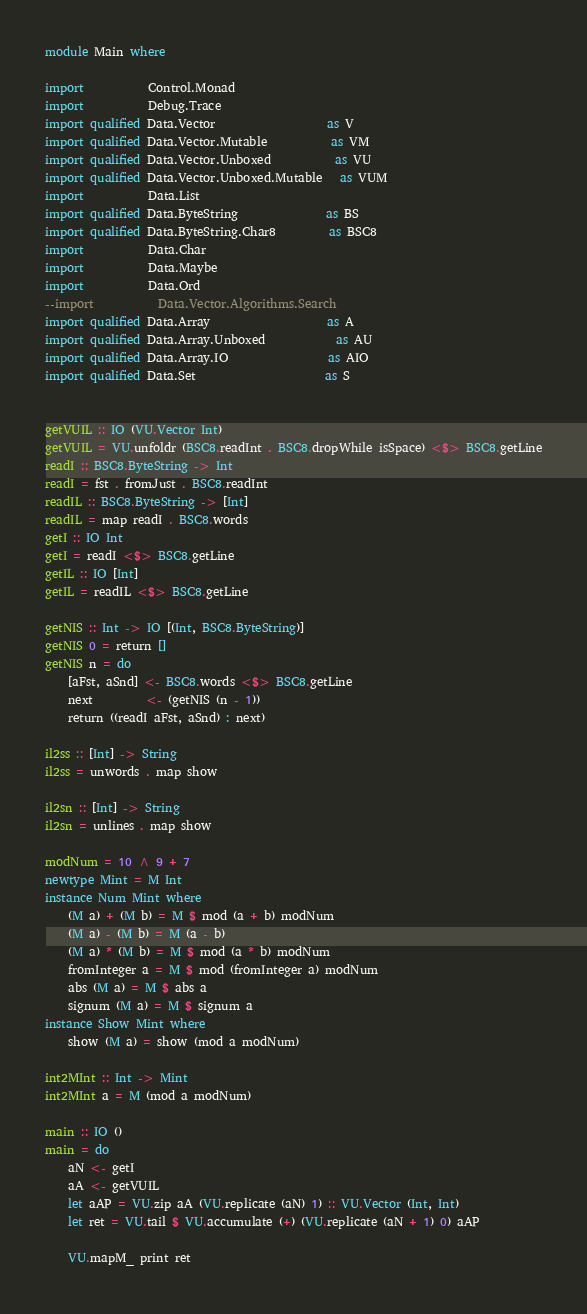Convert code to text. <code><loc_0><loc_0><loc_500><loc_500><_Haskell_>module Main where

import           Control.Monad
import           Debug.Trace
import qualified Data.Vector                   as V
import qualified Data.Vector.Mutable           as VM
import qualified Data.Vector.Unboxed           as VU
import qualified Data.Vector.Unboxed.Mutable   as VUM
import           Data.List
import qualified Data.ByteString               as BS
import qualified Data.ByteString.Char8         as BSC8
import           Data.Char
import           Data.Maybe
import           Data.Ord
--import           Data.Vector.Algorithms.Search
import qualified Data.Array                    as A
import qualified Data.Array.Unboxed            as AU
import qualified Data.Array.IO                 as AIO
import qualified Data.Set                      as S


getVUIL :: IO (VU.Vector Int)
getVUIL = VU.unfoldr (BSC8.readInt . BSC8.dropWhile isSpace) <$> BSC8.getLine
readI :: BSC8.ByteString -> Int
readI = fst . fromJust . BSC8.readInt
readIL :: BSC8.ByteString -> [Int]
readIL = map readI . BSC8.words
getI :: IO Int
getI = readI <$> BSC8.getLine
getIL :: IO [Int]
getIL = readIL <$> BSC8.getLine

getNIS :: Int -> IO [(Int, BSC8.ByteString)]
getNIS 0 = return []
getNIS n = do
    [aFst, aSnd] <- BSC8.words <$> BSC8.getLine
    next         <- (getNIS (n - 1))
    return ((readI aFst, aSnd) : next)

il2ss :: [Int] -> String
il2ss = unwords . map show

il2sn :: [Int] -> String
il2sn = unlines . map show

modNum = 10 ^ 9 + 7
newtype Mint = M Int
instance Num Mint where
    (M a) + (M b) = M $ mod (a + b) modNum
    (M a) - (M b) = M (a - b)
    (M a) * (M b) = M $ mod (a * b) modNum
    fromInteger a = M $ mod (fromInteger a) modNum
    abs (M a) = M $ abs a
    signum (M a) = M $ signum a
instance Show Mint where
    show (M a) = show (mod a modNum)

int2MInt :: Int -> Mint
int2MInt a = M (mod a modNum)

main :: IO ()
main = do
    aN <- getI
    aA <- getVUIL
    let aAP = VU.zip aA (VU.replicate (aN) 1) :: VU.Vector (Int, Int)
    let ret = VU.tail $ VU.accumulate (+) (VU.replicate (aN + 1) 0) aAP

    VU.mapM_ print ret
</code> 